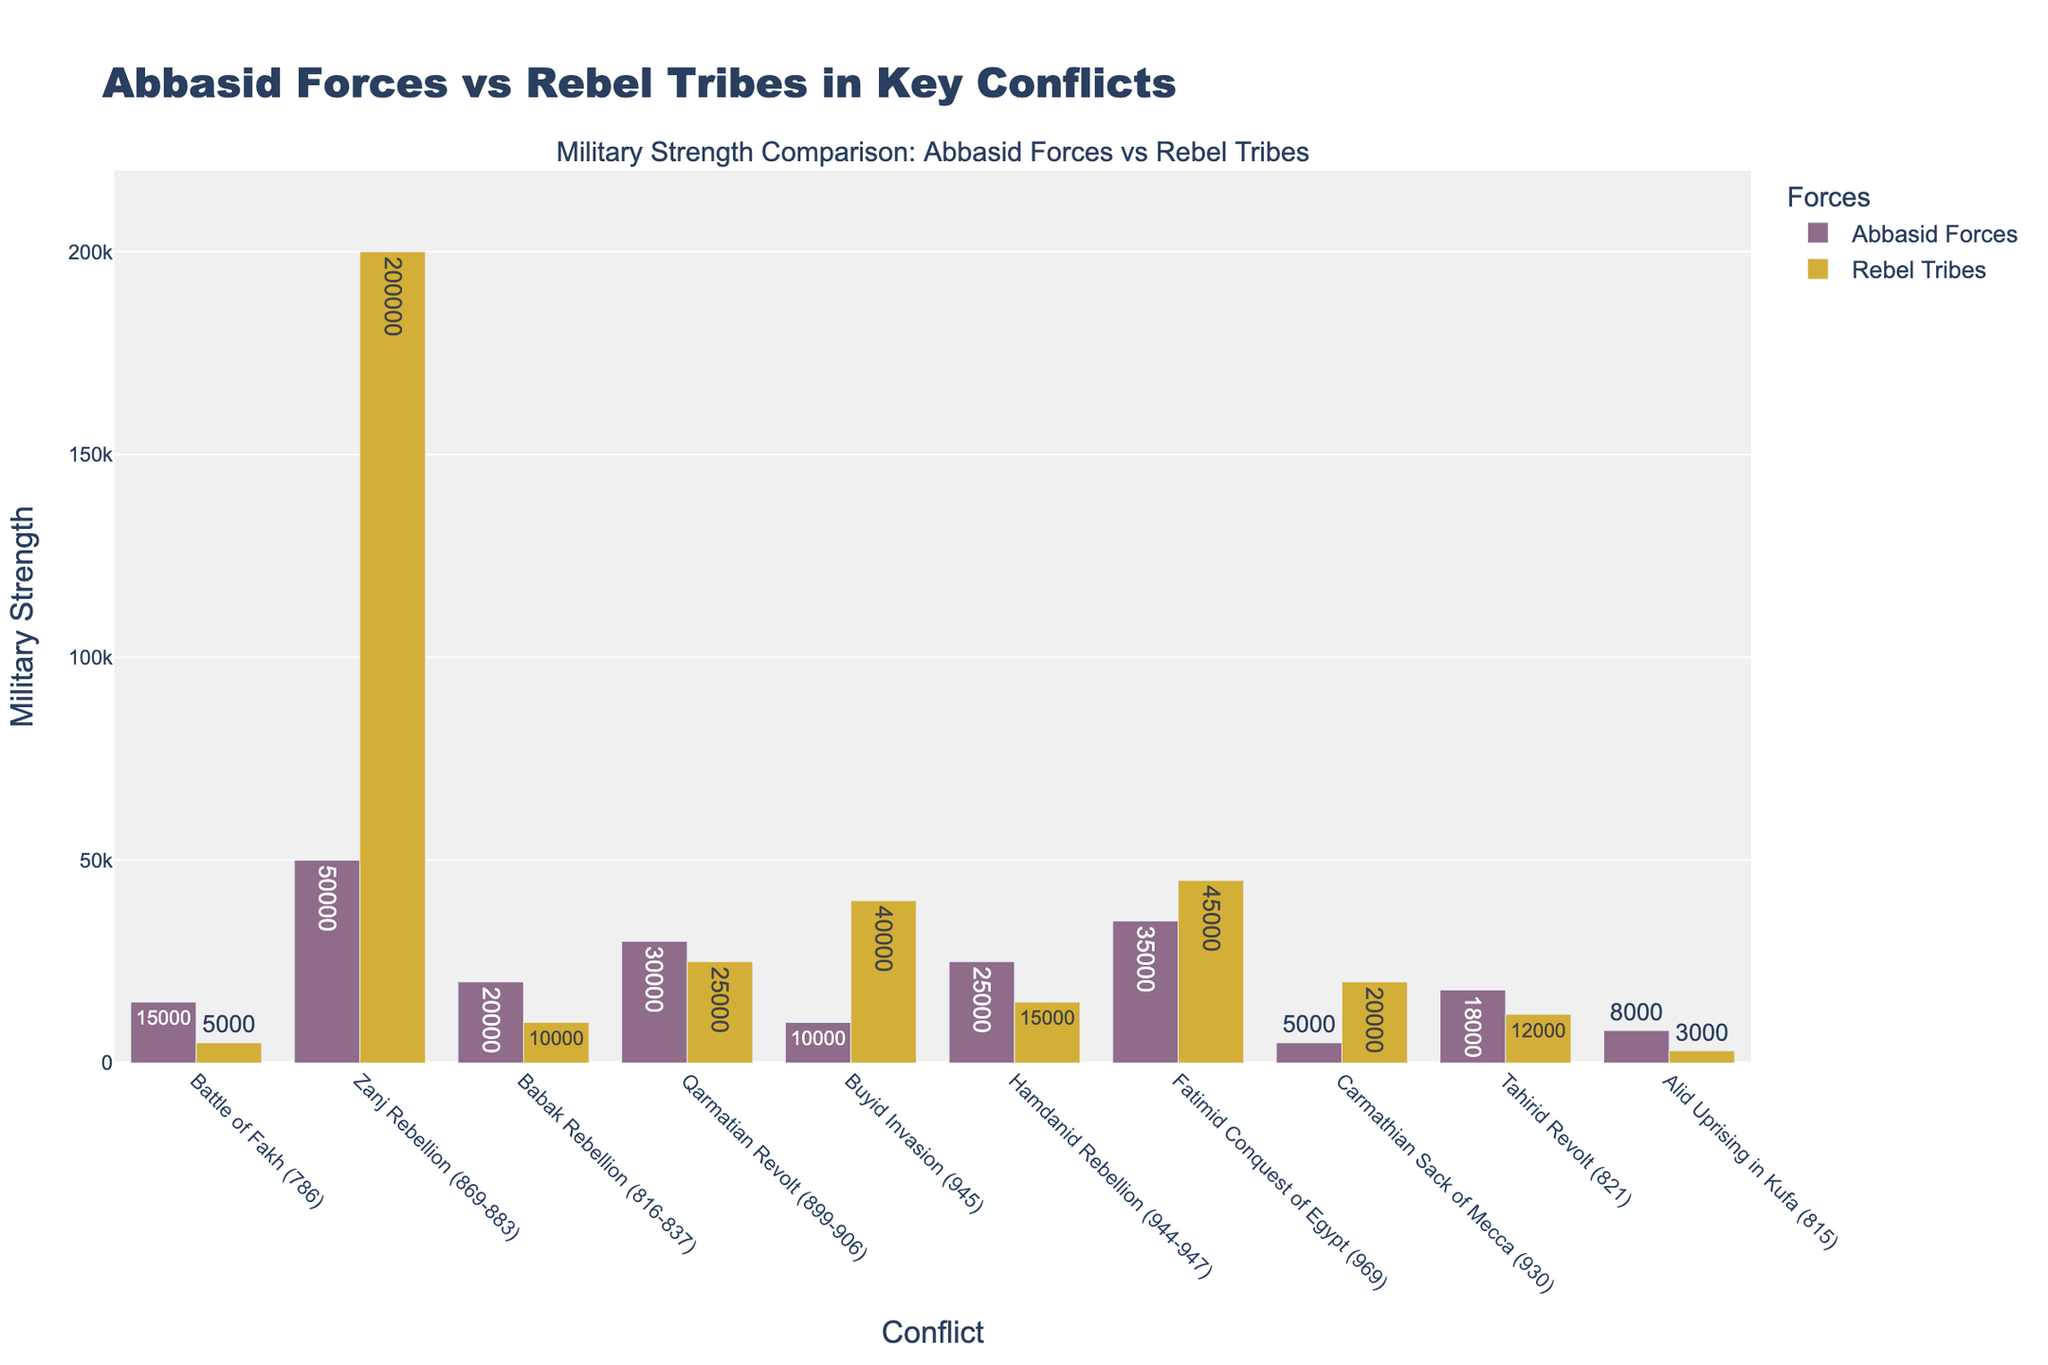What conflict has the largest disparity in military strength between Abbasid forces and rebel tribes? To find the conflict with the largest disparity, examine the difference between Abbasid forces and rebel tribes for each conflict. The Zanj Rebellion (869-883) shows the largest disparity, with the Abbasid forces at 50,000 and rebel tribes at 200,000, a difference of 150,000.
Answer: Zanj Rebellion (869-883) Which conflicts show the Abbasid forces having fewer troops than the rebel tribes? Look at all the conflicts and compare the heights of the bars representing Abbasid forces and rebel tribes. The battles where the Abbasid forces are fewer are the Zanj Rebellion (869-883), Buyid Invasion (945), Fatimid Conquest of Egypt (969), and Carmathian Sack of Mecca (930).
Answer: Zanj Rebellion (869-883), Buyid Invasion (945), Fatimid Conquest of Egypt (969), Carmathian Sack of Mecca (930) What is the total combined military strength of both Abbasid forces and rebel tribes during the Carmathian Sack of Mecca (930)? Add the military strength of Abbasid forces (5,000) and rebel tribes (20,000) during the Carmathian Sack of Mecca. The combined military strength is 5,000 + 20,000 = 25,000.
Answer: 25,000 Which conflict featured the least military strength for the Abbasid forces? Identify the conflict with the smallest height for the Abbasid forces' bar. The conflict with the least military strength for the Abbasid forces is the Carmathian Sack of Mecca (930), with 5,000 troops.
Answer: Carmathian Sack of Mecca (930) Is there any conflict where Abbasid forces outnumber rebel tribes by more than 2:1? Calculate for each conflict if Abbasid forces are more than twice the rebel tribes’ numbers. In the Battle of Fakh (786), Abbasid forces have 15,000 troops while rebel tribes have 5,000, satisfying the condition (15,000 is more than twice 5,000).
Answer: Battle of Fakh (786) Which conflict shows the closest military strength between Abbasid forces and rebel tribes? Identify the conflict where the bars for Abbasid forces and rebel tribes are closest in height. The Qarmatian Revolt (899-906) shows 30,000 Abbasid forces and 25,000 rebel tribes, making it the closest.
Answer: Qarmatian Revolt (899-906) What is the average military strength of Abbasid forces across all conflicts? Sum the Abbasid forces' troops across all conflicts and divide by the number of conflicts. The total is 15,000 + 50,000 + 20,000 + 30,000 + 10,000 + 25,000 + 35,000 + 5,000 + 18,000 + 8,000 = 216,000. Dividing by 10 conflicts gives an average strength of 216,000 / 10 = 21,600.
Answer: 21,600 In terms of visual representation, which conflict has the tallest bar height for rebel tribes? Look for the conflict with the tallest bar representing the rebel tribes. The Zanj Rebellion (869-883) has the tallest bar for rebel tribes, with 200,000 troops.
Answer: Zanj Rebellion (869-883) Which conflict had more troops in total, the Fatimid Conquest of Egypt (969) or the Hamdanid Rebellion (944-947)? Sum the troops for both Abbasid forces and rebel tribes in each conflict and compare. For the Fatimid Conquest of Egypt: 35,000 (Abbasid) + 45,000 (rebel) = 80,000. For the Hamdanid Rebellion: 25,000 (Abbasid) + 15,000 (rebel) = 40,000.
Answer: Fatimid Conquest of Egypt (969) By how much did the Abbasid forces outnumber the rebel tribes in the Alid Uprising in Kufa (815)? Subtract the rebel tribes' troops from the Abbasid forces' troops for the Alid Uprising in Kufa. Abbasid forces were 8,000 and rebel tribes were 3,000, so the difference is 8,000 - 3,000 = 5,000.
Answer: 5,000 